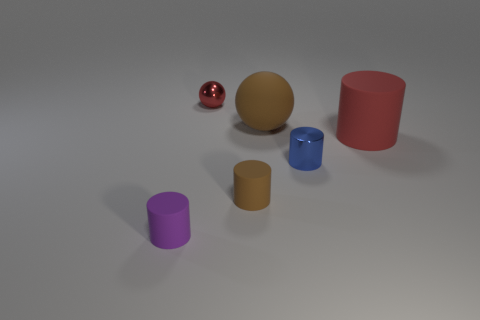Subtract 1 cylinders. How many cylinders are left? 3 Add 3 metallic cylinders. How many objects exist? 9 Subtract all balls. How many objects are left? 4 Subtract all small objects. Subtract all big brown matte spheres. How many objects are left? 1 Add 1 tiny metallic spheres. How many tiny metallic spheres are left? 2 Add 2 small cyan metallic spheres. How many small cyan metallic spheres exist? 2 Subtract 1 red spheres. How many objects are left? 5 